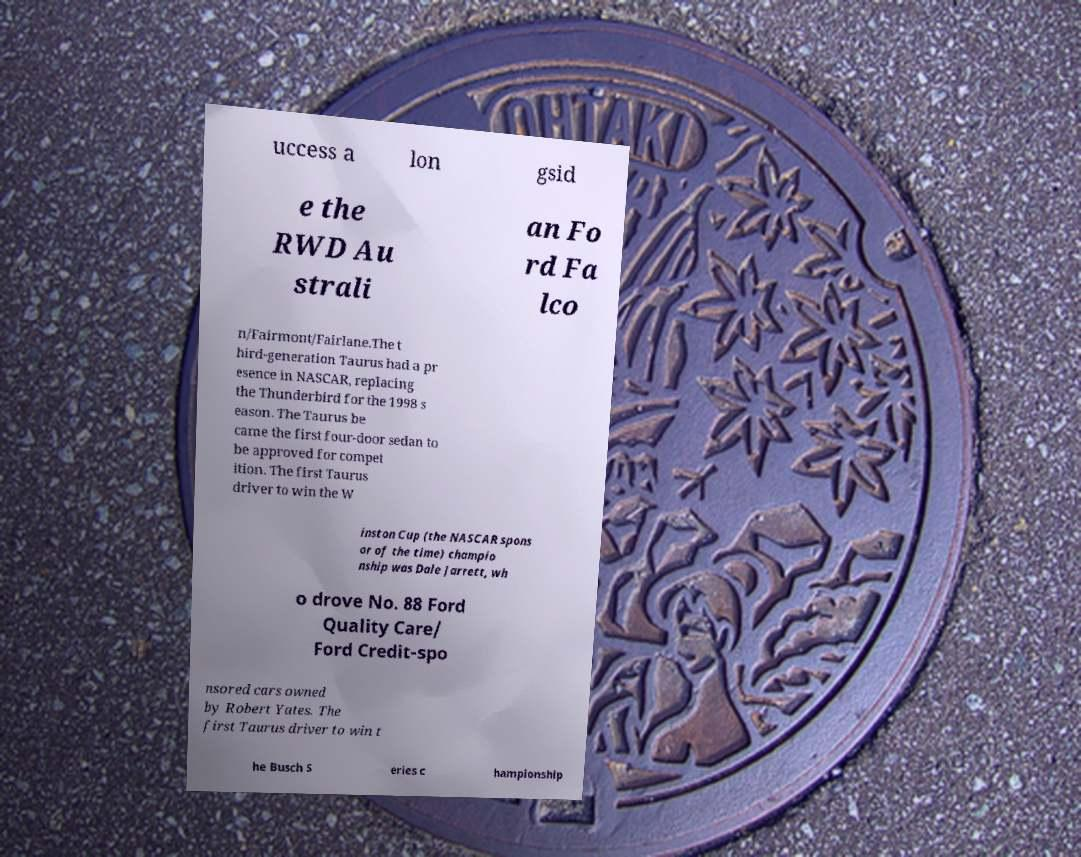Can you read and provide the text displayed in the image?This photo seems to have some interesting text. Can you extract and type it out for me? uccess a lon gsid e the RWD Au strali an Fo rd Fa lco n/Fairmont/Fairlane.The t hird-generation Taurus had a pr esence in NASCAR, replacing the Thunderbird for the 1998 s eason. The Taurus be came the first four-door sedan to be approved for compet ition. The first Taurus driver to win the W inston Cup (the NASCAR spons or of the time) champio nship was Dale Jarrett, wh o drove No. 88 Ford Quality Care/ Ford Credit-spo nsored cars owned by Robert Yates. The first Taurus driver to win t he Busch S eries c hampionship 